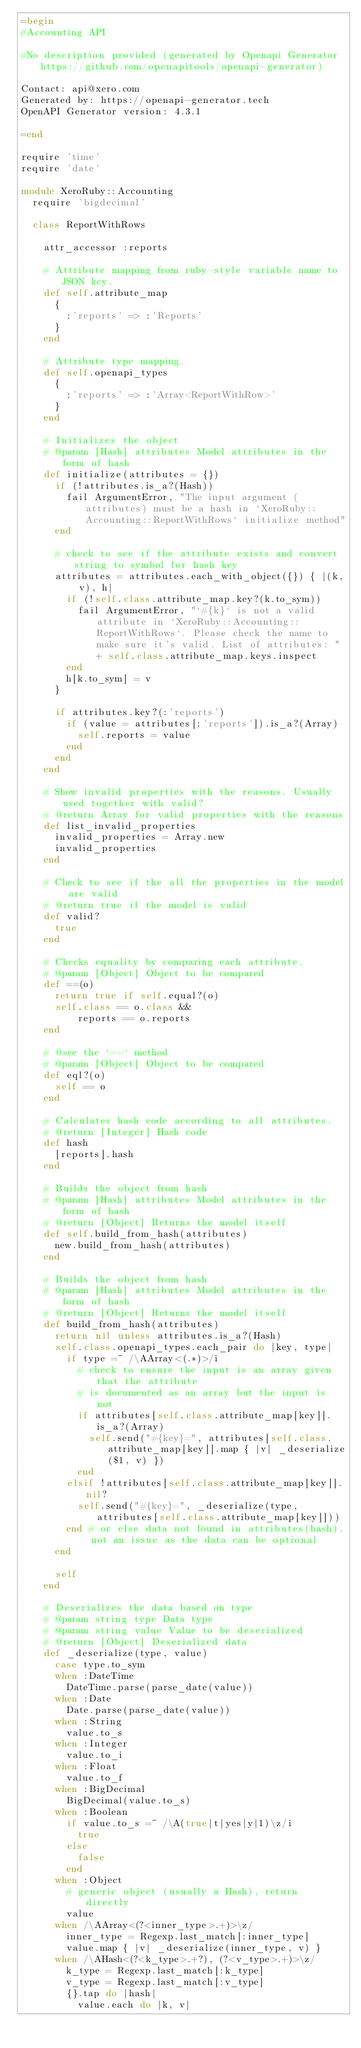Convert code to text. <code><loc_0><loc_0><loc_500><loc_500><_Ruby_>=begin
#Accounting API

#No description provided (generated by Openapi Generator https://github.com/openapitools/openapi-generator)

Contact: api@xero.com
Generated by: https://openapi-generator.tech
OpenAPI Generator version: 4.3.1

=end

require 'time'
require 'date'

module XeroRuby::Accounting
  require 'bigdecimal'

  class ReportWithRows

    attr_accessor :reports
    
    # Attribute mapping from ruby-style variable name to JSON key.
    def self.attribute_map
      {
        :'reports' => :'Reports'
      }
    end

    # Attribute type mapping.
    def self.openapi_types
      {
        :'reports' => :'Array<ReportWithRow>'
      }
    end

    # Initializes the object
    # @param [Hash] attributes Model attributes in the form of hash
    def initialize(attributes = {})
      if (!attributes.is_a?(Hash))
        fail ArgumentError, "The input argument (attributes) must be a hash in `XeroRuby::Accounting::ReportWithRows` initialize method"
      end

      # check to see if the attribute exists and convert string to symbol for hash key
      attributes = attributes.each_with_object({}) { |(k, v), h|
        if (!self.class.attribute_map.key?(k.to_sym))
          fail ArgumentError, "`#{k}` is not a valid attribute in `XeroRuby::Accounting::ReportWithRows`. Please check the name to make sure it's valid. List of attributes: " + self.class.attribute_map.keys.inspect
        end
        h[k.to_sym] = v
      }

      if attributes.key?(:'reports')
        if (value = attributes[:'reports']).is_a?(Array)
          self.reports = value
        end
      end
    end

    # Show invalid properties with the reasons. Usually used together with valid?
    # @return Array for valid properties with the reasons
    def list_invalid_properties
      invalid_properties = Array.new
      invalid_properties
    end

    # Check to see if the all the properties in the model are valid
    # @return true if the model is valid
    def valid?
      true
    end

    # Checks equality by comparing each attribute.
    # @param [Object] Object to be compared
    def ==(o)
      return true if self.equal?(o)
      self.class == o.class &&
          reports == o.reports
    end

    # @see the `==` method
    # @param [Object] Object to be compared
    def eql?(o)
      self == o
    end

    # Calculates hash code according to all attributes.
    # @return [Integer] Hash code
    def hash
      [reports].hash
    end

    # Builds the object from hash
    # @param [Hash] attributes Model attributes in the form of hash
    # @return [Object] Returns the model itself
    def self.build_from_hash(attributes)
      new.build_from_hash(attributes)
    end

    # Builds the object from hash
    # @param [Hash] attributes Model attributes in the form of hash
    # @return [Object] Returns the model itself
    def build_from_hash(attributes)
      return nil unless attributes.is_a?(Hash)
      self.class.openapi_types.each_pair do |key, type|
        if type =~ /\AArray<(.*)>/i
          # check to ensure the input is an array given that the attribute
          # is documented as an array but the input is not
          if attributes[self.class.attribute_map[key]].is_a?(Array)
            self.send("#{key}=", attributes[self.class.attribute_map[key]].map { |v| _deserialize($1, v) })
          end
        elsif !attributes[self.class.attribute_map[key]].nil?
          self.send("#{key}=", _deserialize(type, attributes[self.class.attribute_map[key]]))
        end # or else data not found in attributes(hash), not an issue as the data can be optional
      end

      self
    end

    # Deserializes the data based on type
    # @param string type Data type
    # @param string value Value to be deserialized
    # @return [Object] Deserialized data
    def _deserialize(type, value)
      case type.to_sym
      when :DateTime
        DateTime.parse(parse_date(value))
      when :Date
        Date.parse(parse_date(value))
      when :String
        value.to_s
      when :Integer
        value.to_i
      when :Float
        value.to_f
      when :BigDecimal
        BigDecimal(value.to_s)
      when :Boolean
        if value.to_s =~ /\A(true|t|yes|y|1)\z/i
          true
        else
          false
        end
      when :Object
        # generic object (usually a Hash), return directly
        value
      when /\AArray<(?<inner_type>.+)>\z/
        inner_type = Regexp.last_match[:inner_type]
        value.map { |v| _deserialize(inner_type, v) }
      when /\AHash<(?<k_type>.+?), (?<v_type>.+)>\z/
        k_type = Regexp.last_match[:k_type]
        v_type = Regexp.last_match[:v_type]
        {}.tap do |hash|
          value.each do |k, v|</code> 